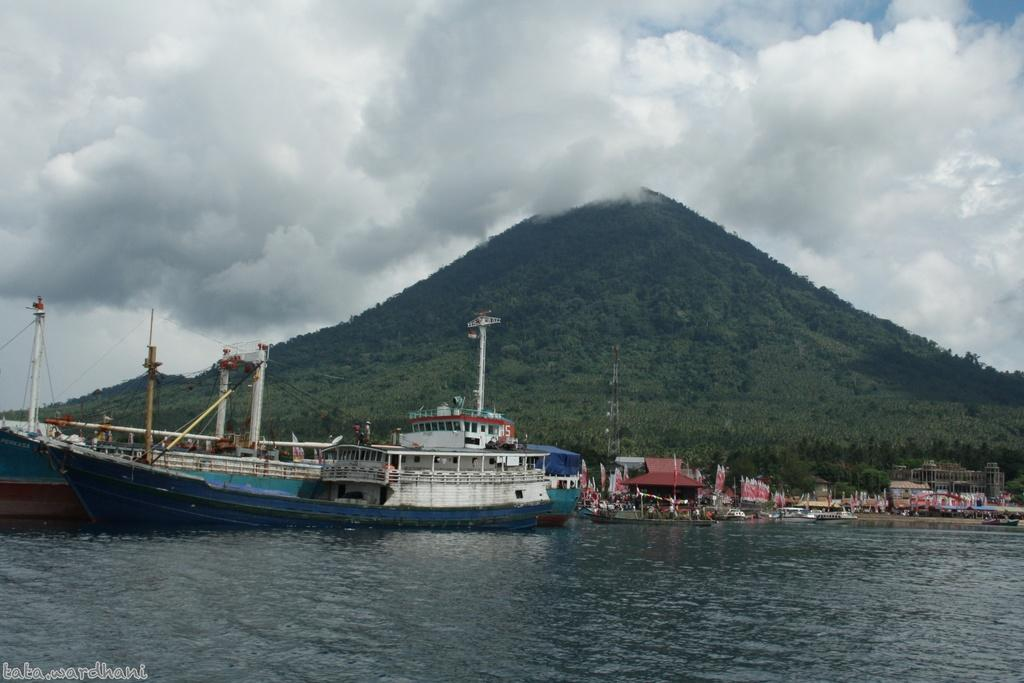What type of landform can be seen in the image? There is a hill in the image. What types of watercraft are present in the image? There are ships and boats in the image. What structures can be seen in the image? There are buildings in the image. What type of vegetation is present in the image? There are trees in the image. What is the purpose of the watermark in the image? The watermark in the bottom left corner of the image is likely for copyright or identification purposes. What is visible in the background of the image? The sky is visible in the background of the image, and there are clouds in the sky. How many matches are present in the image? There are no matches visible in the image. What type of mark can be seen on the trees in the image? There is no specific mark mentioned on the trees in the image; they are simply described as trees. 